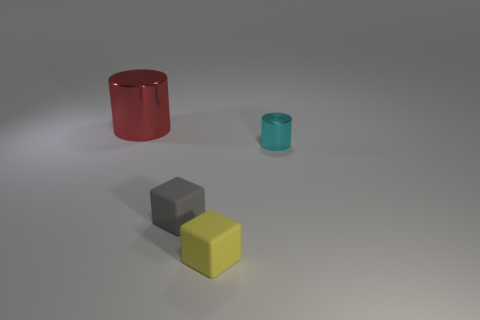Add 4 gray things. How many objects exist? 8 Subtract all large yellow metallic cubes. Subtract all matte objects. How many objects are left? 2 Add 4 large metallic cylinders. How many large metallic cylinders are left? 5 Add 2 rubber cubes. How many rubber cubes exist? 4 Subtract 1 red cylinders. How many objects are left? 3 